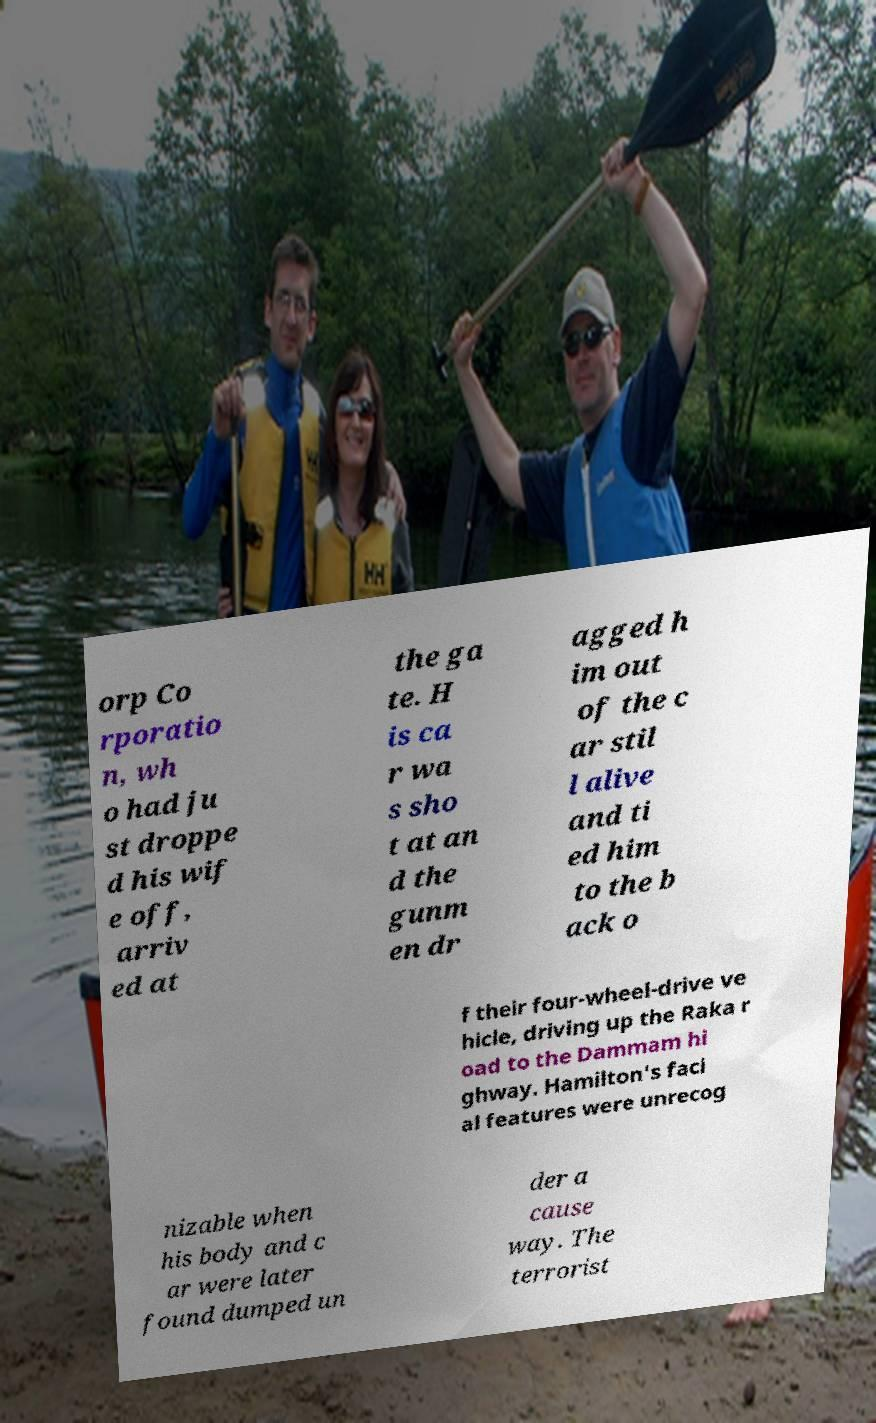Please identify and transcribe the text found in this image. orp Co rporatio n, wh o had ju st droppe d his wif e off, arriv ed at the ga te. H is ca r wa s sho t at an d the gunm en dr agged h im out of the c ar stil l alive and ti ed him to the b ack o f their four-wheel-drive ve hicle, driving up the Raka r oad to the Dammam hi ghway. Hamilton's faci al features were unrecog nizable when his body and c ar were later found dumped un der a cause way. The terrorist 